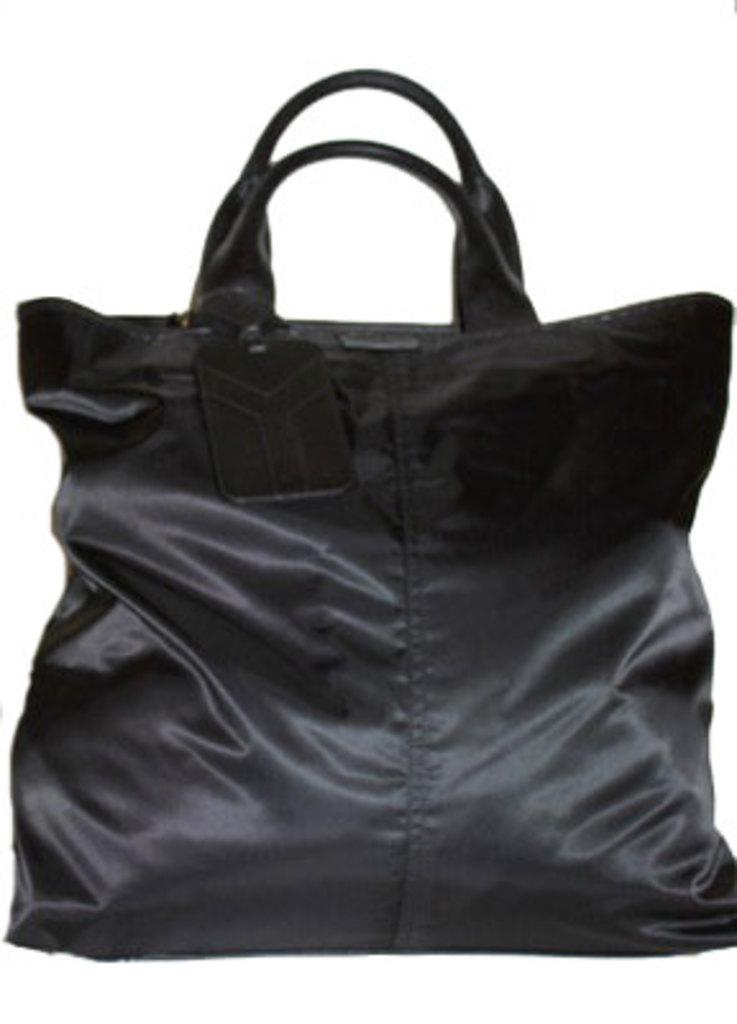What type of material is the bag made of in the image? The bag is made of leather. What feature can be seen attached to the bag in the image? There is a holder attached to the bag. What type of glass is used to make the shoe in the image? There is no shoe present in the image, and therefore no glass can be used to make it. 